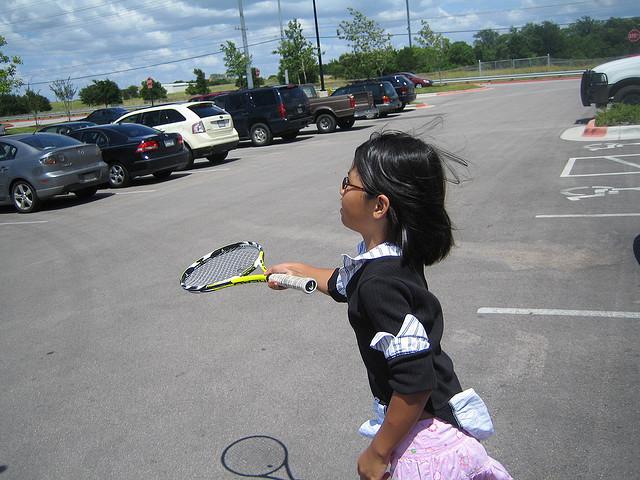How many handicap parking spaces are visible?
Answer briefly. 2. What is the girl holding?
Write a very short answer. Tennis racket. How many vehicles are in the parking lot?
Give a very brief answer. 8. What is the boy doing?
Keep it brief. Tennis. 